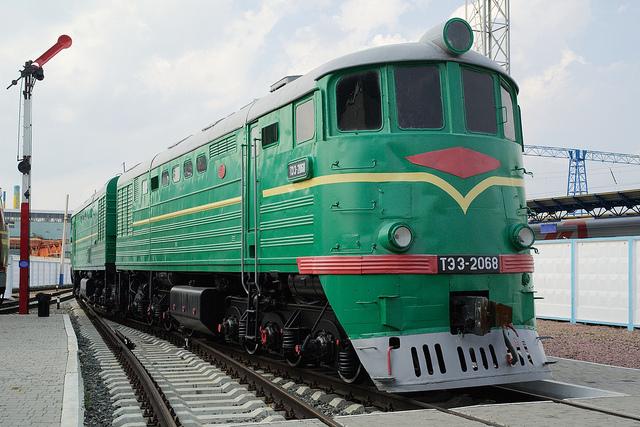What color is the train?
Answer briefly. Green. Can people ride this train?
Write a very short answer. Yes. What is the only letter in the train's identifying number sequence?
Short answer required. T. What is the train number?
Keep it brief. T33-2068. 